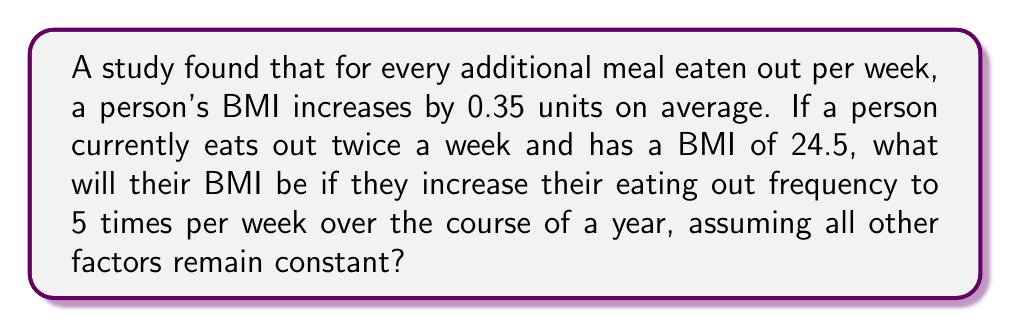Provide a solution to this math problem. Let's approach this step-by-step:

1. Understand the given information:
   * BMI increases by 0.35 units for each additional meal eaten out per week
   * Current eating out frequency: 2 times per week
   * Current BMI: 24.5
   * New eating out frequency: 5 times per week

2. Calculate the change in eating out frequency:
   $\Delta \text{frequency} = 5 - 2 = 3$ additional meals per week

3. Calculate the total change in BMI:
   $\Delta \text{BMI} = 0.35 \times \Delta \text{frequency}$
   $\Delta \text{BMI} = 0.35 \times 3 = 1.05$ units

4. Calculate the new BMI:
   $\text{New BMI} = \text{Current BMI} + \Delta \text{BMI}$
   $\text{New BMI} = 24.5 + 1.05 = 25.55$

Therefore, if the person increases their eating out frequency from 2 to 5 times per week over the course of a year, their BMI is expected to increase from 24.5 to 25.55, assuming all other factors remain constant.
Answer: 25.55 